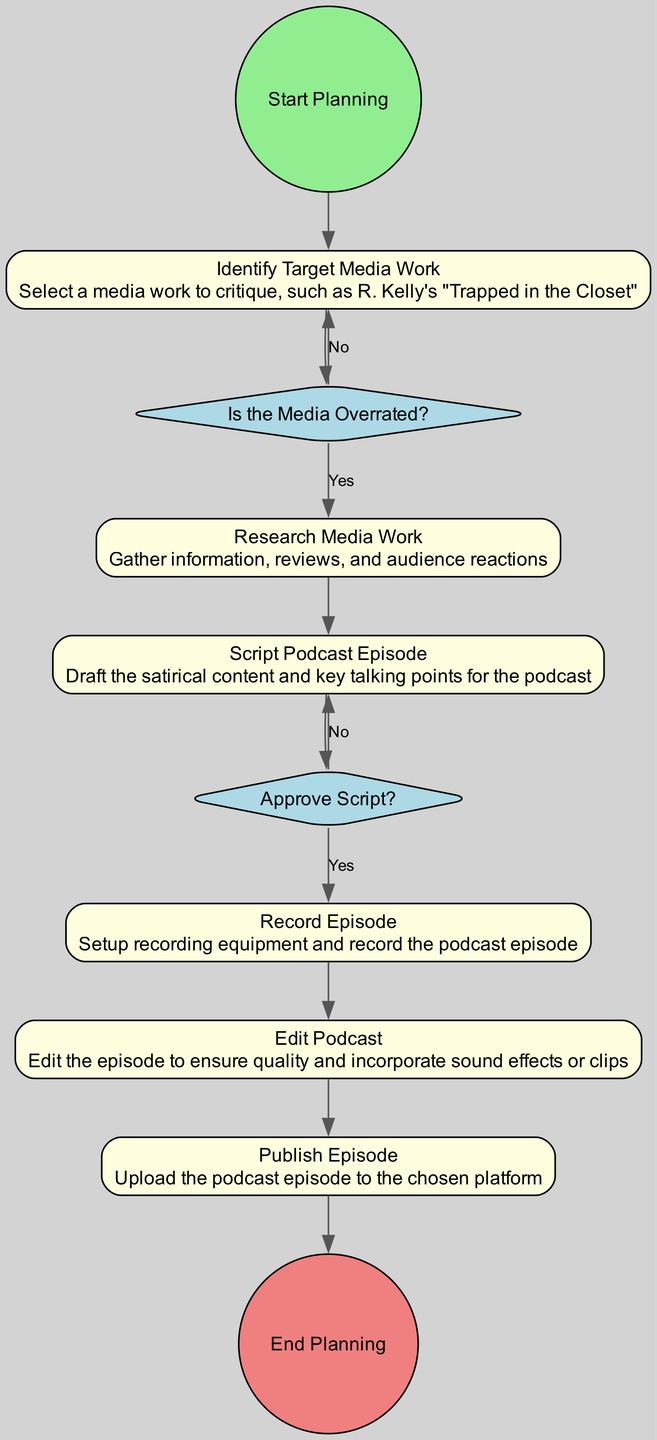What's the first activity in the diagram? The first item after "Start Planning" is "Identify Target Media Work." This is the initial step in the flow.
Answer: Identify Target Media Work How many decision points are there in the diagram? There are two decision points: "Is the Media Overrated?" and "Approve Script?" Therefore, the count is 2.
Answer: 2 What happens if the media is not rated as overrated? If the media is not rated as overrated, the flow indicates a return to "Identify Target Media Work," suggesting choosing a different media work.
Answer: Identify Target Media Work What is the last activity before ending the planning? The final activity prior to reaching "End Planning" is "Publish Episode," which directly precedes the end event.
Answer: Publish Episode What does the decision "Approve Script?" lead to if the answer is 'No'? If the script is not approved, the diagram indicates a return to "Script Podcast Episode," signifying the need for revisions before proceeding.
Answer: Script Podcast Episode What is the sequence flow from "Research Media Work"? The sequence flows from "Research Media Work" to "Script Podcast Episode," establishing that after researching, scripting is the next step.
Answer: Script Podcast Episode How many activities are in the diagram? The activities listed are "Identify Target Media Work," "Research Media Work," "Script Podcast Episode," "Record Episode," "Edit Podcast," and "Publish Episode," totaling six activities.
Answer: 6 If the script is approved, what happens next? Upon approval of the script, the flow leads to "Record Episode," indicating that recording follows the approval process.
Answer: Record Episode How many edges connect the nodes in the diagram? By analyzing the connections, there are ten edges depicted by "SequenceFlow" between the various elements of the diagram.
Answer: 10 